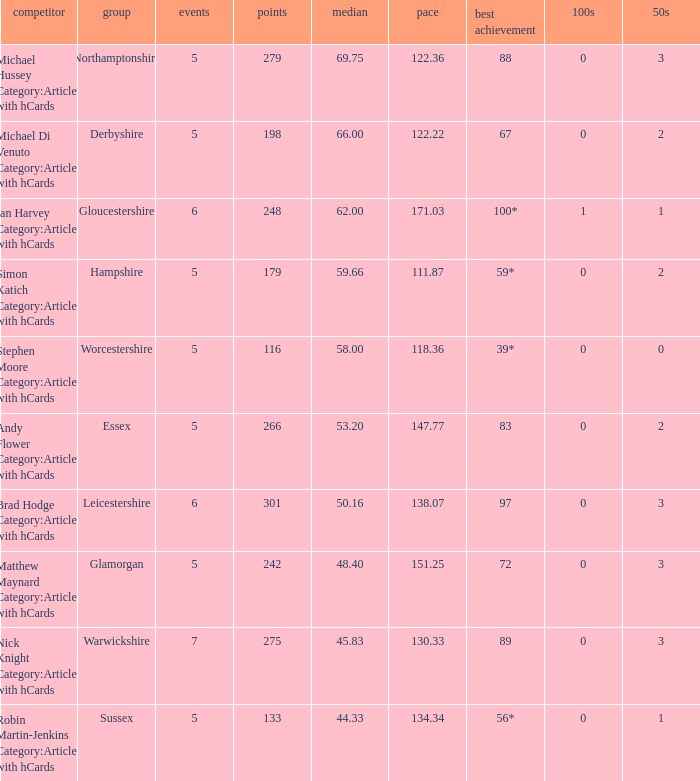If the highest score is 88, what are the 50s? 3.0. 